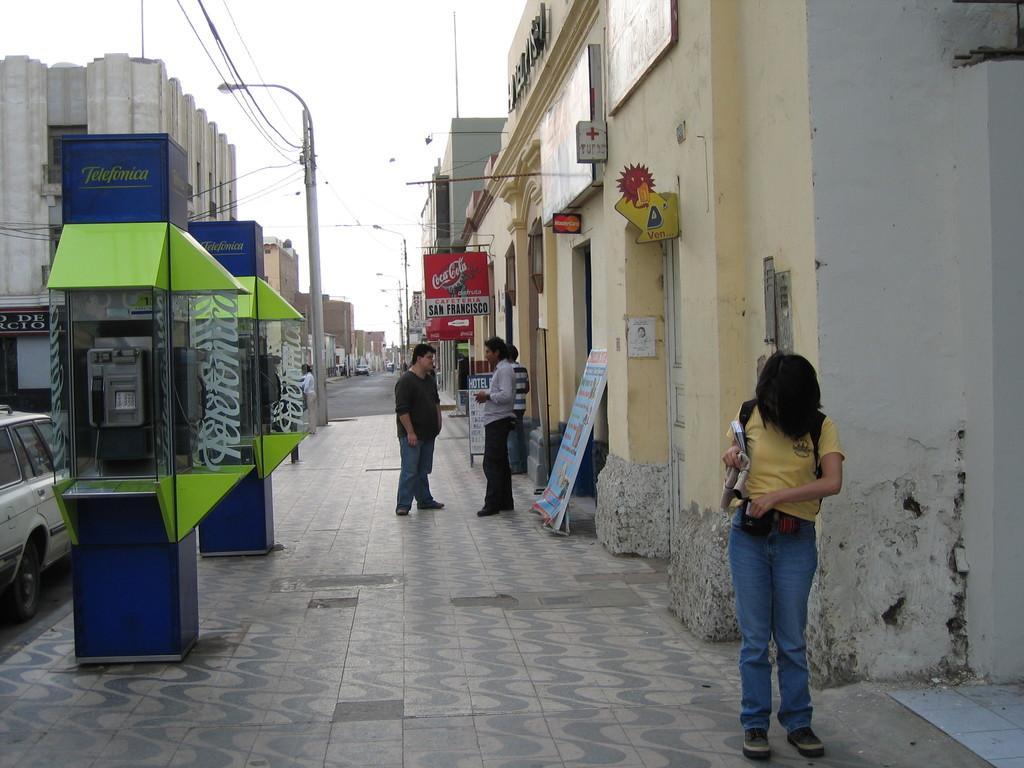Please provide a concise description of this image. In this picture, on the right side, we can see people standing on the footpath in front of the buildings. On the left side, we can see public telephone booths, light poles, wires. We can also see vehicles on the road and buildings on the left side. 